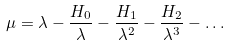Convert formula to latex. <formula><loc_0><loc_0><loc_500><loc_500>\mu = \lambda - \frac { H _ { 0 } } { \lambda } - \frac { H _ { 1 } } { \lambda ^ { 2 } } - \frac { H _ { 2 } } { \lambda ^ { 3 } } - \dots</formula> 